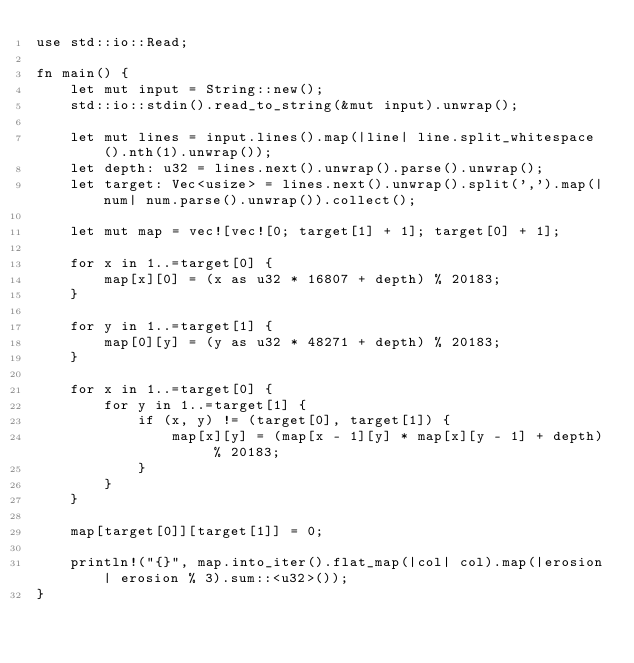<code> <loc_0><loc_0><loc_500><loc_500><_Rust_>use std::io::Read;

fn main() {
    let mut input = String::new();
    std::io::stdin().read_to_string(&mut input).unwrap();

    let mut lines = input.lines().map(|line| line.split_whitespace().nth(1).unwrap());
    let depth: u32 = lines.next().unwrap().parse().unwrap();
    let target: Vec<usize> = lines.next().unwrap().split(',').map(|num| num.parse().unwrap()).collect();

    let mut map = vec![vec![0; target[1] + 1]; target[0] + 1];

    for x in 1..=target[0] {
        map[x][0] = (x as u32 * 16807 + depth) % 20183;
    }

    for y in 1..=target[1] {
        map[0][y] = (y as u32 * 48271 + depth) % 20183;
    }

    for x in 1..=target[0] {
        for y in 1..=target[1] {
            if (x, y) != (target[0], target[1]) {
                map[x][y] = (map[x - 1][y] * map[x][y - 1] + depth) % 20183;
            }
        }
    }

    map[target[0]][target[1]] = 0;

    println!("{}", map.into_iter().flat_map(|col| col).map(|erosion| erosion % 3).sum::<u32>());
}
</code> 